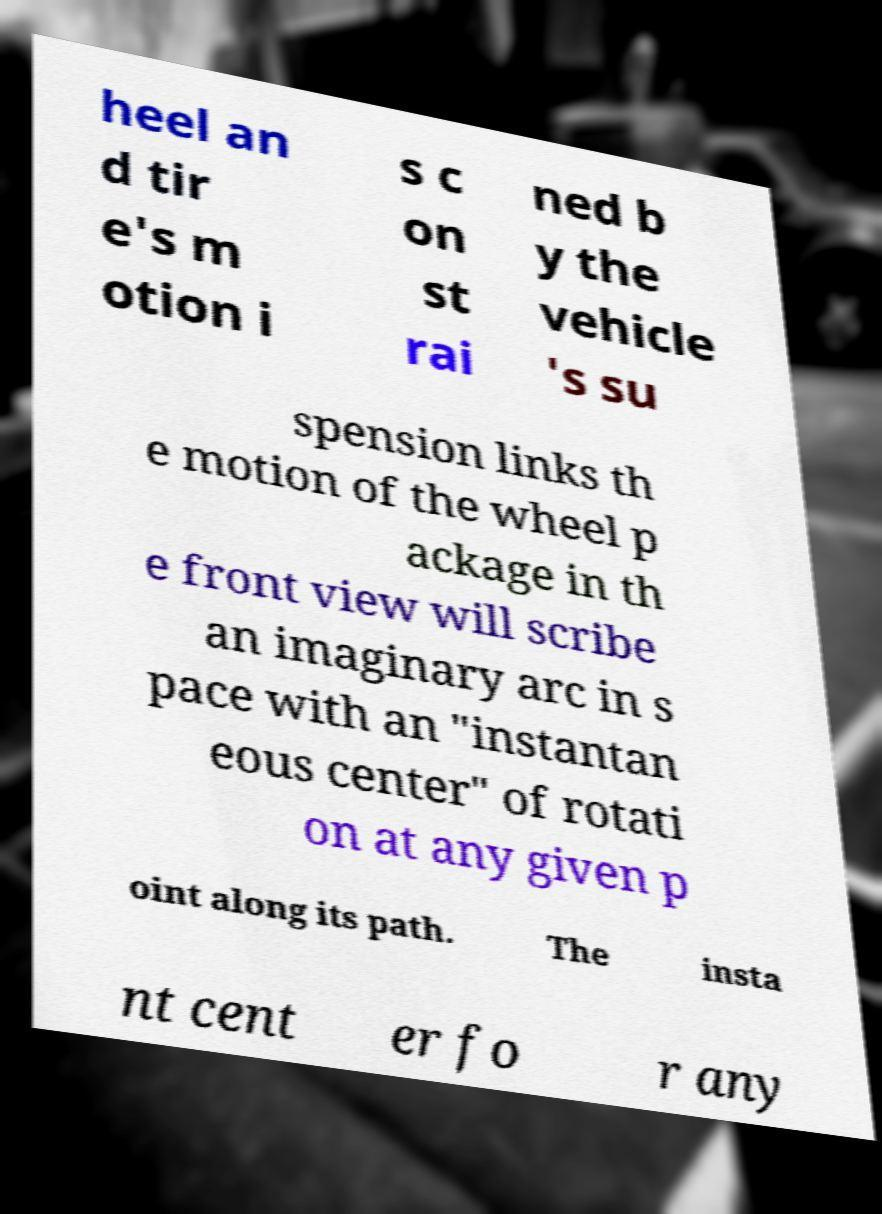Can you accurately transcribe the text from the provided image for me? heel an d tir e's m otion i s c on st rai ned b y the vehicle 's su spension links th e motion of the wheel p ackage in th e front view will scribe an imaginary arc in s pace with an "instantan eous center" of rotati on at any given p oint along its path. The insta nt cent er fo r any 